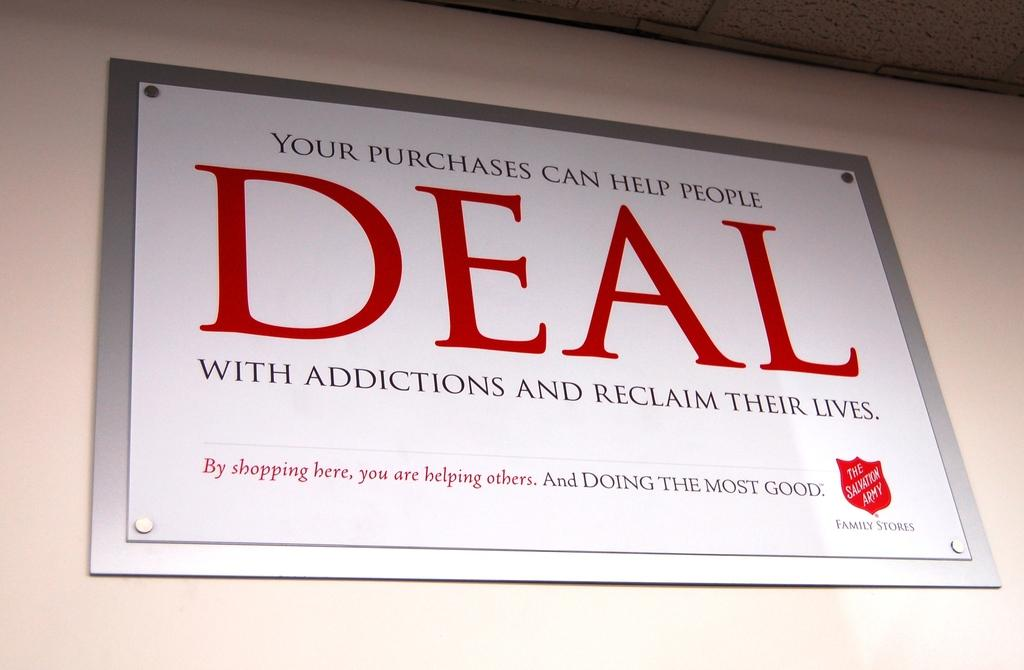<image>
Provide a brief description of the given image. A card framed in silver says DEAL in red. 